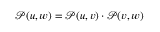Convert formula to latex. <formula><loc_0><loc_0><loc_500><loc_500>\mathcal { P } ( u , w ) = \mathcal { P } ( u , v ) \cdot \mathcal { P } ( v , w )</formula> 